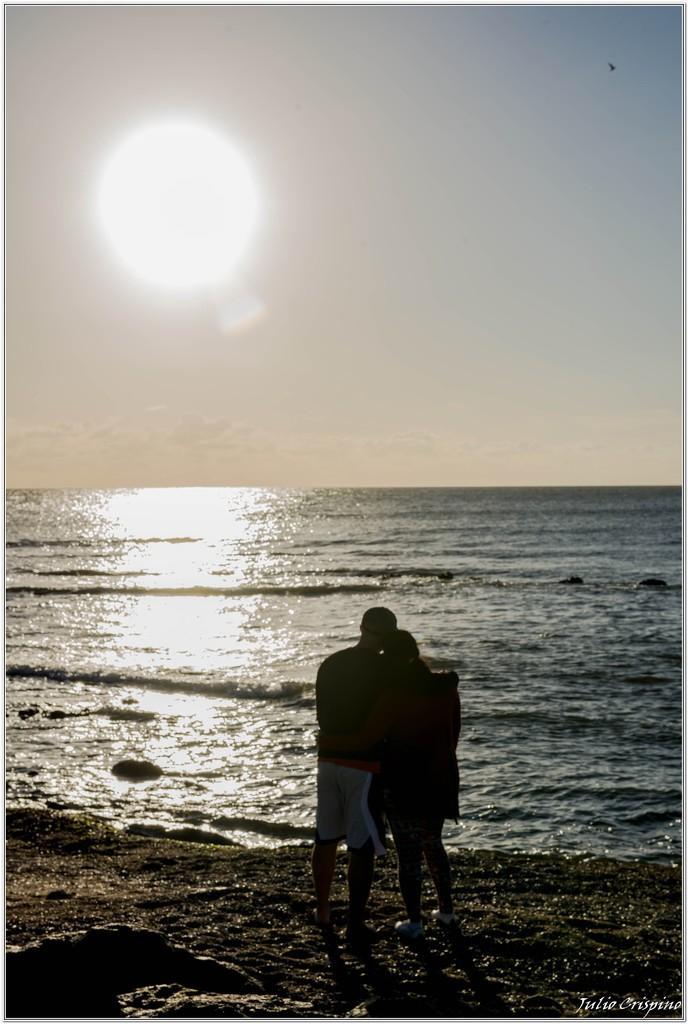In one or two sentences, can you explain what this image depicts? In this image I can see two persons standing on the ground. To the side of these people I can see the water. In the background there is a sun and the sky. 